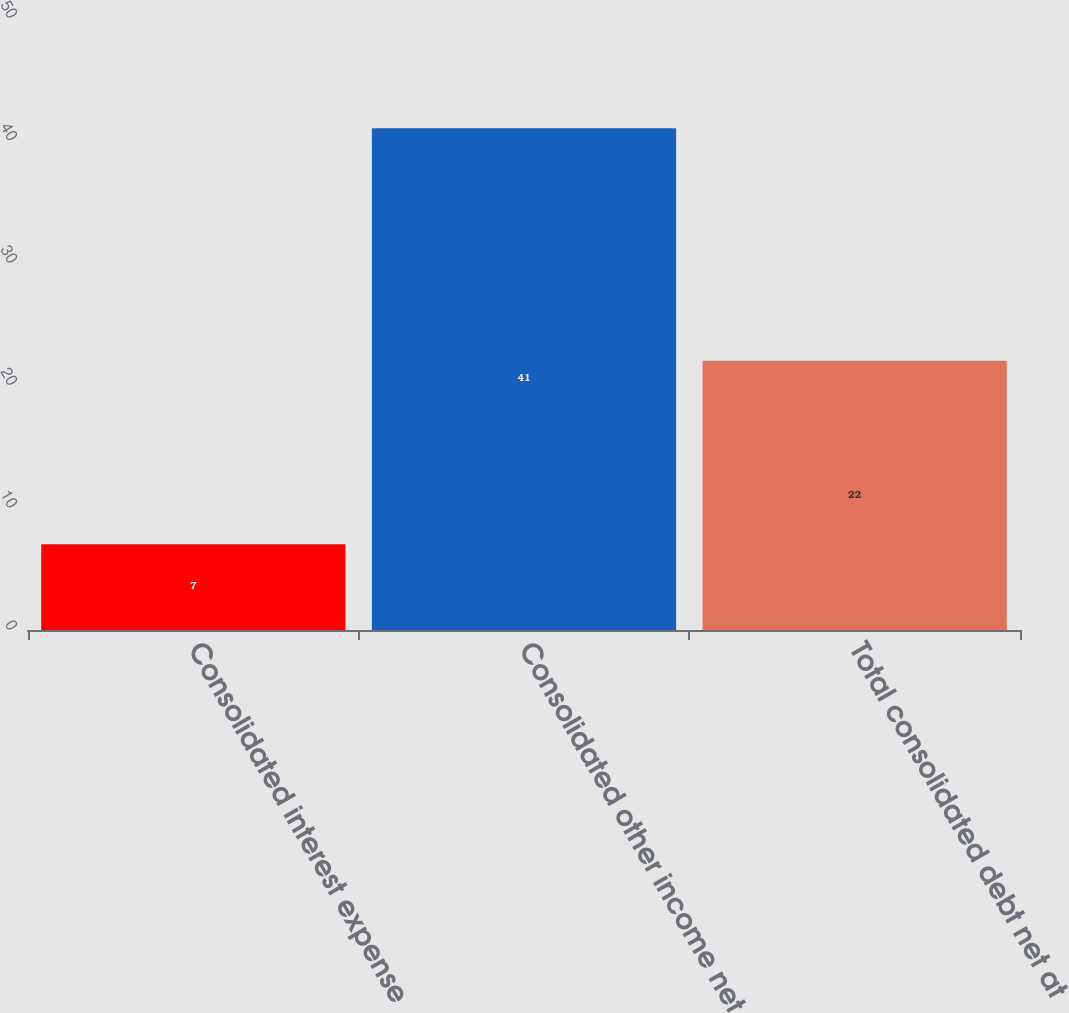Convert chart. <chart><loc_0><loc_0><loc_500><loc_500><bar_chart><fcel>Consolidated interest expense<fcel>Consolidated other income net<fcel>Total consolidated debt net at<nl><fcel>7<fcel>41<fcel>22<nl></chart> 